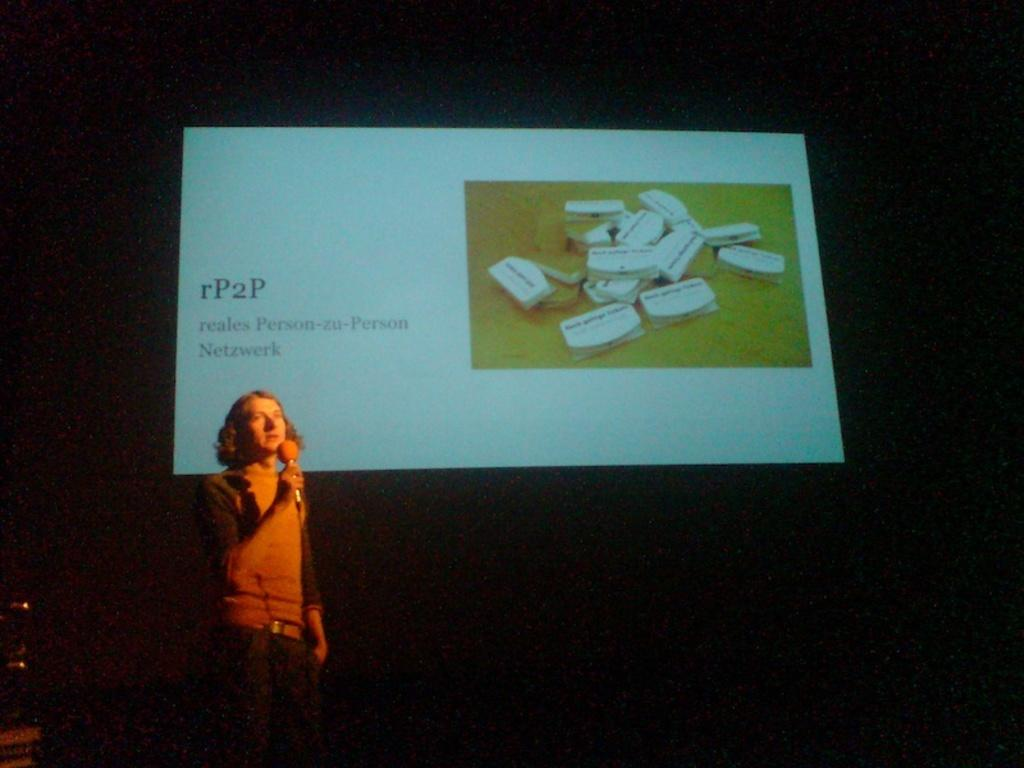What is the main subject of the image? There is a person in the image. What is the person holding in the image? The person is holding a microphone. What can be seen in the background of the image? There is a screen in the background of the image. What is displayed on the screen? The screen displays a group of objects and text. What type of creature is standing next to the person holding the microphone? There is no creature present in the image; it only features a person holding a microphone and a screen in the background. How many legs can be seen on the person holding the microphone? The image does not show the person's legs, so it is impossible to determine the number of legs. 